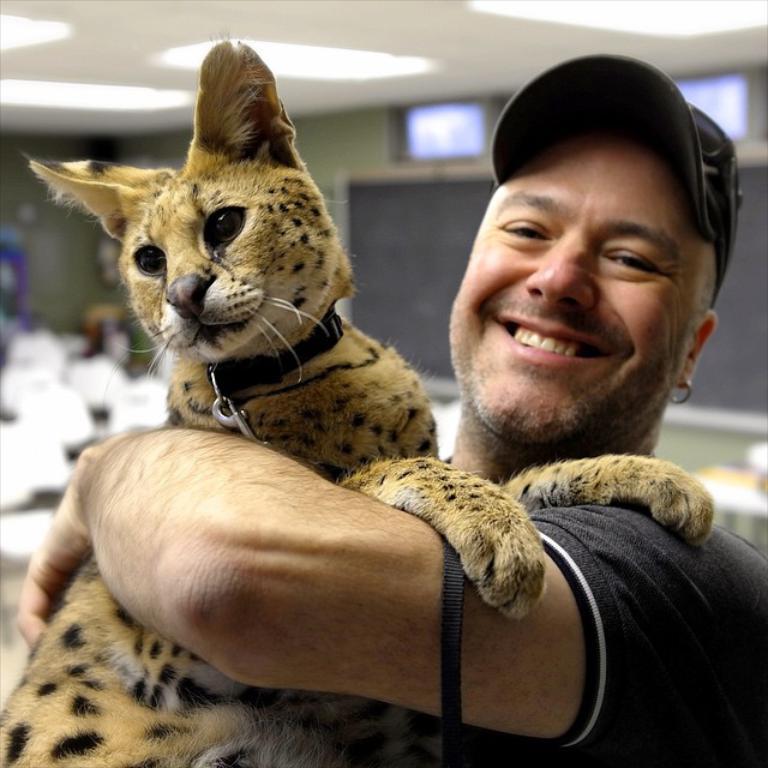Could you give a brief overview of what you see in this image? In the image there is a man with grey t-shirt and cap holding a wild cat, this is clicked inside a hall, there are lights over the ceiling. 